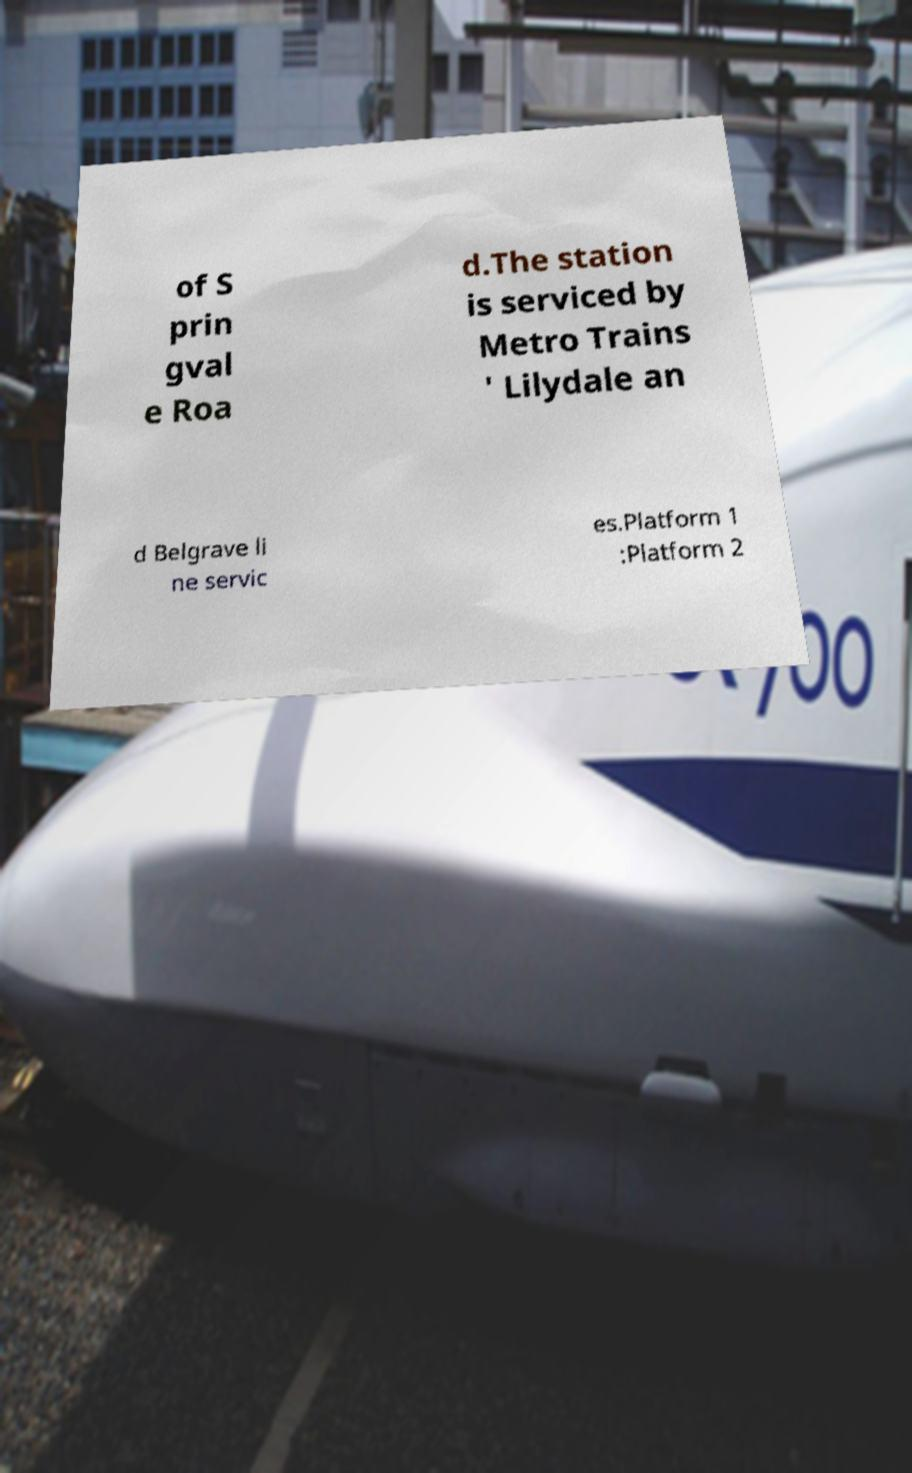Could you assist in decoding the text presented in this image and type it out clearly? of S prin gval e Roa d.The station is serviced by Metro Trains ' Lilydale an d Belgrave li ne servic es.Platform 1 :Platform 2 